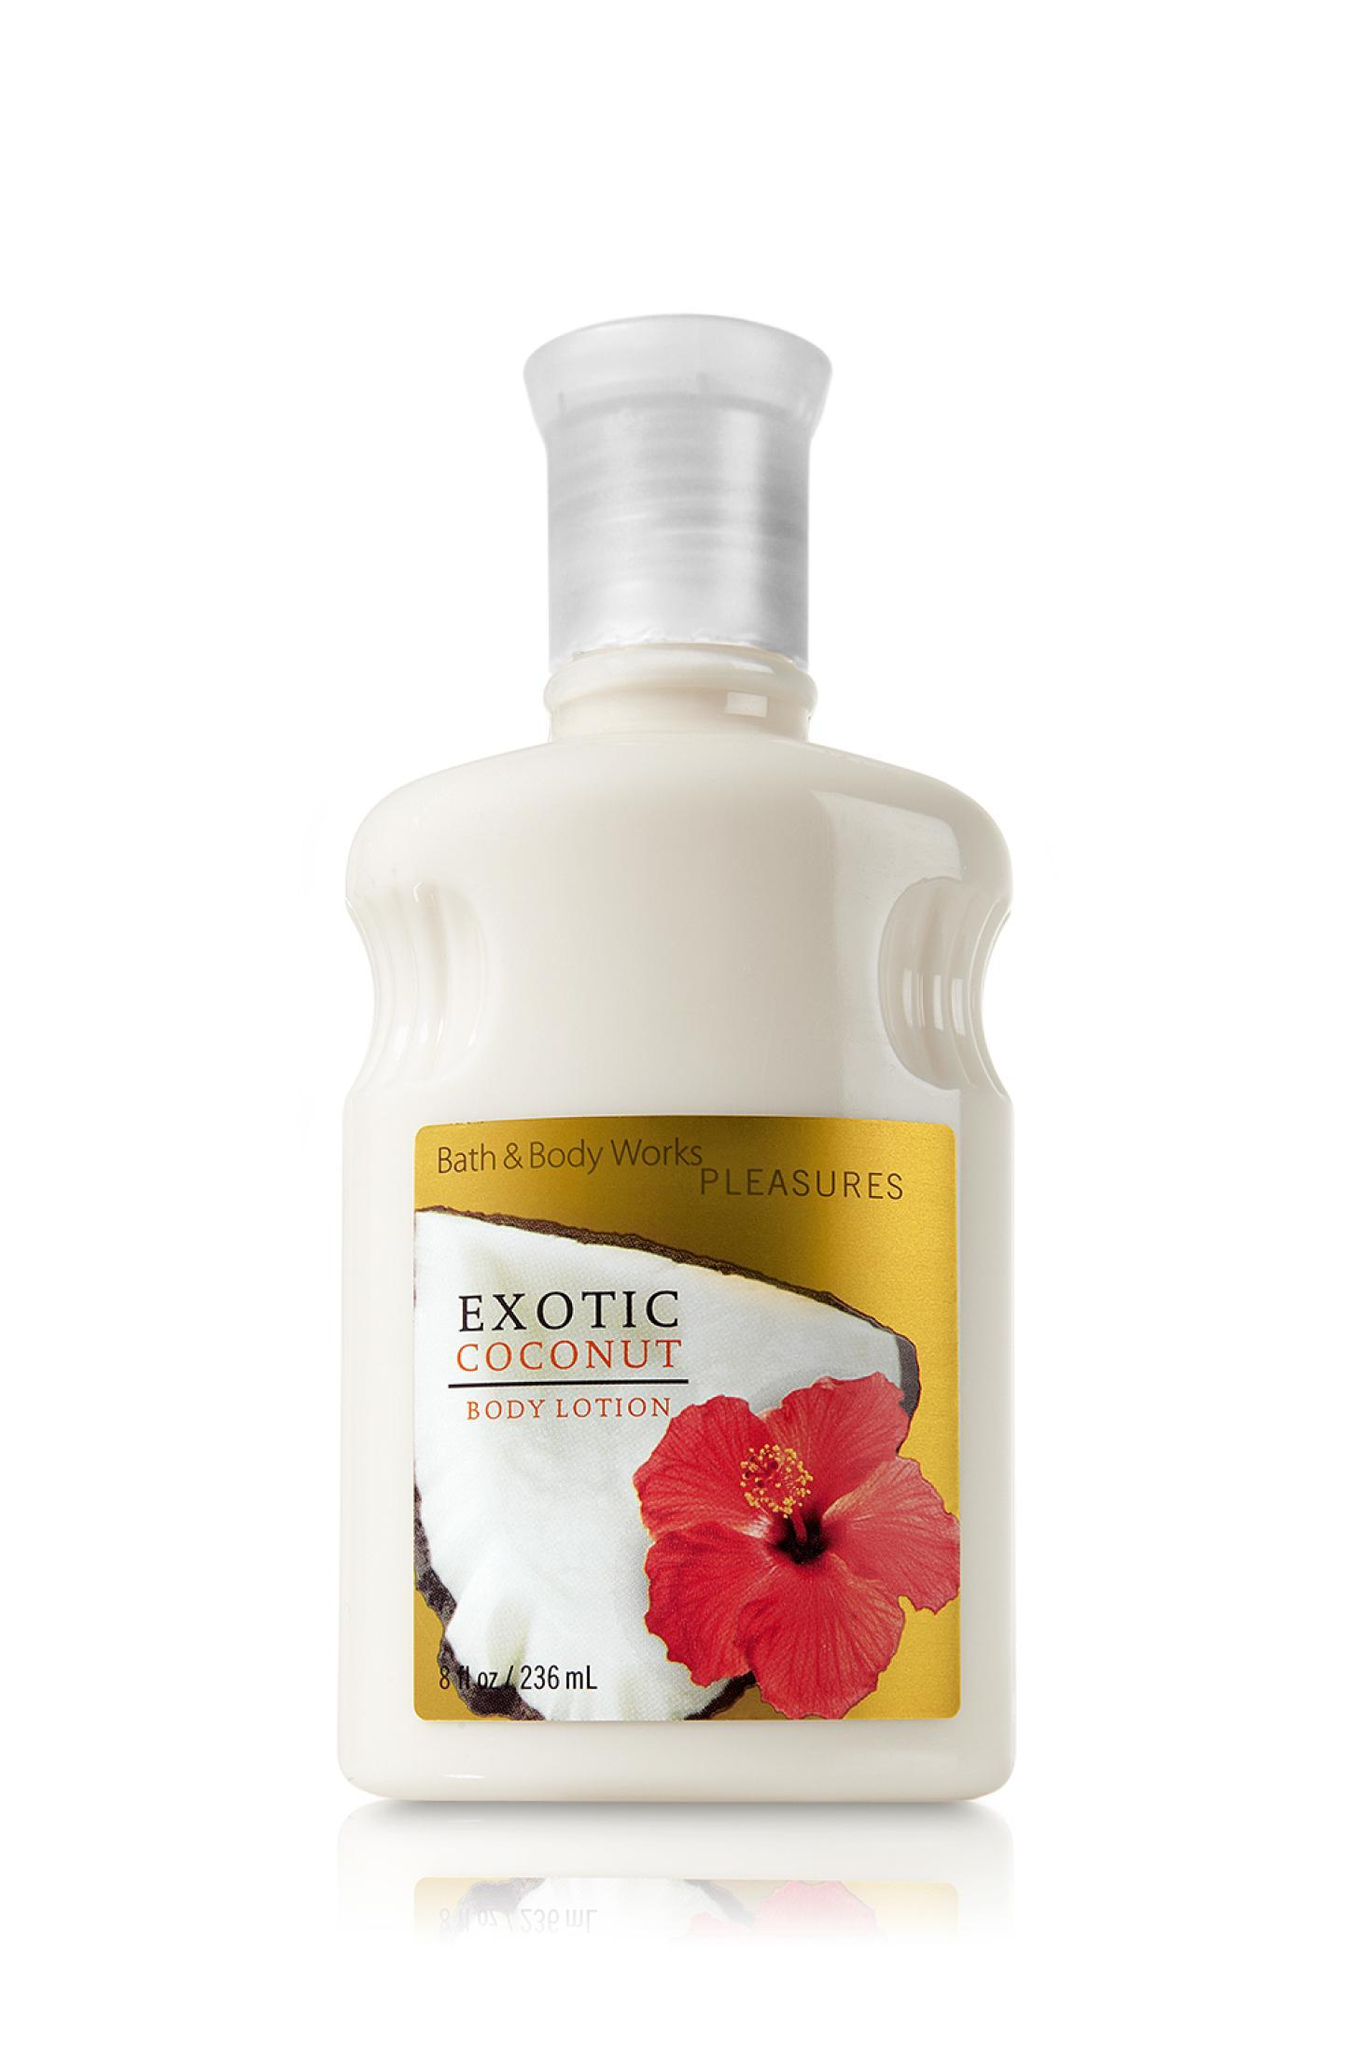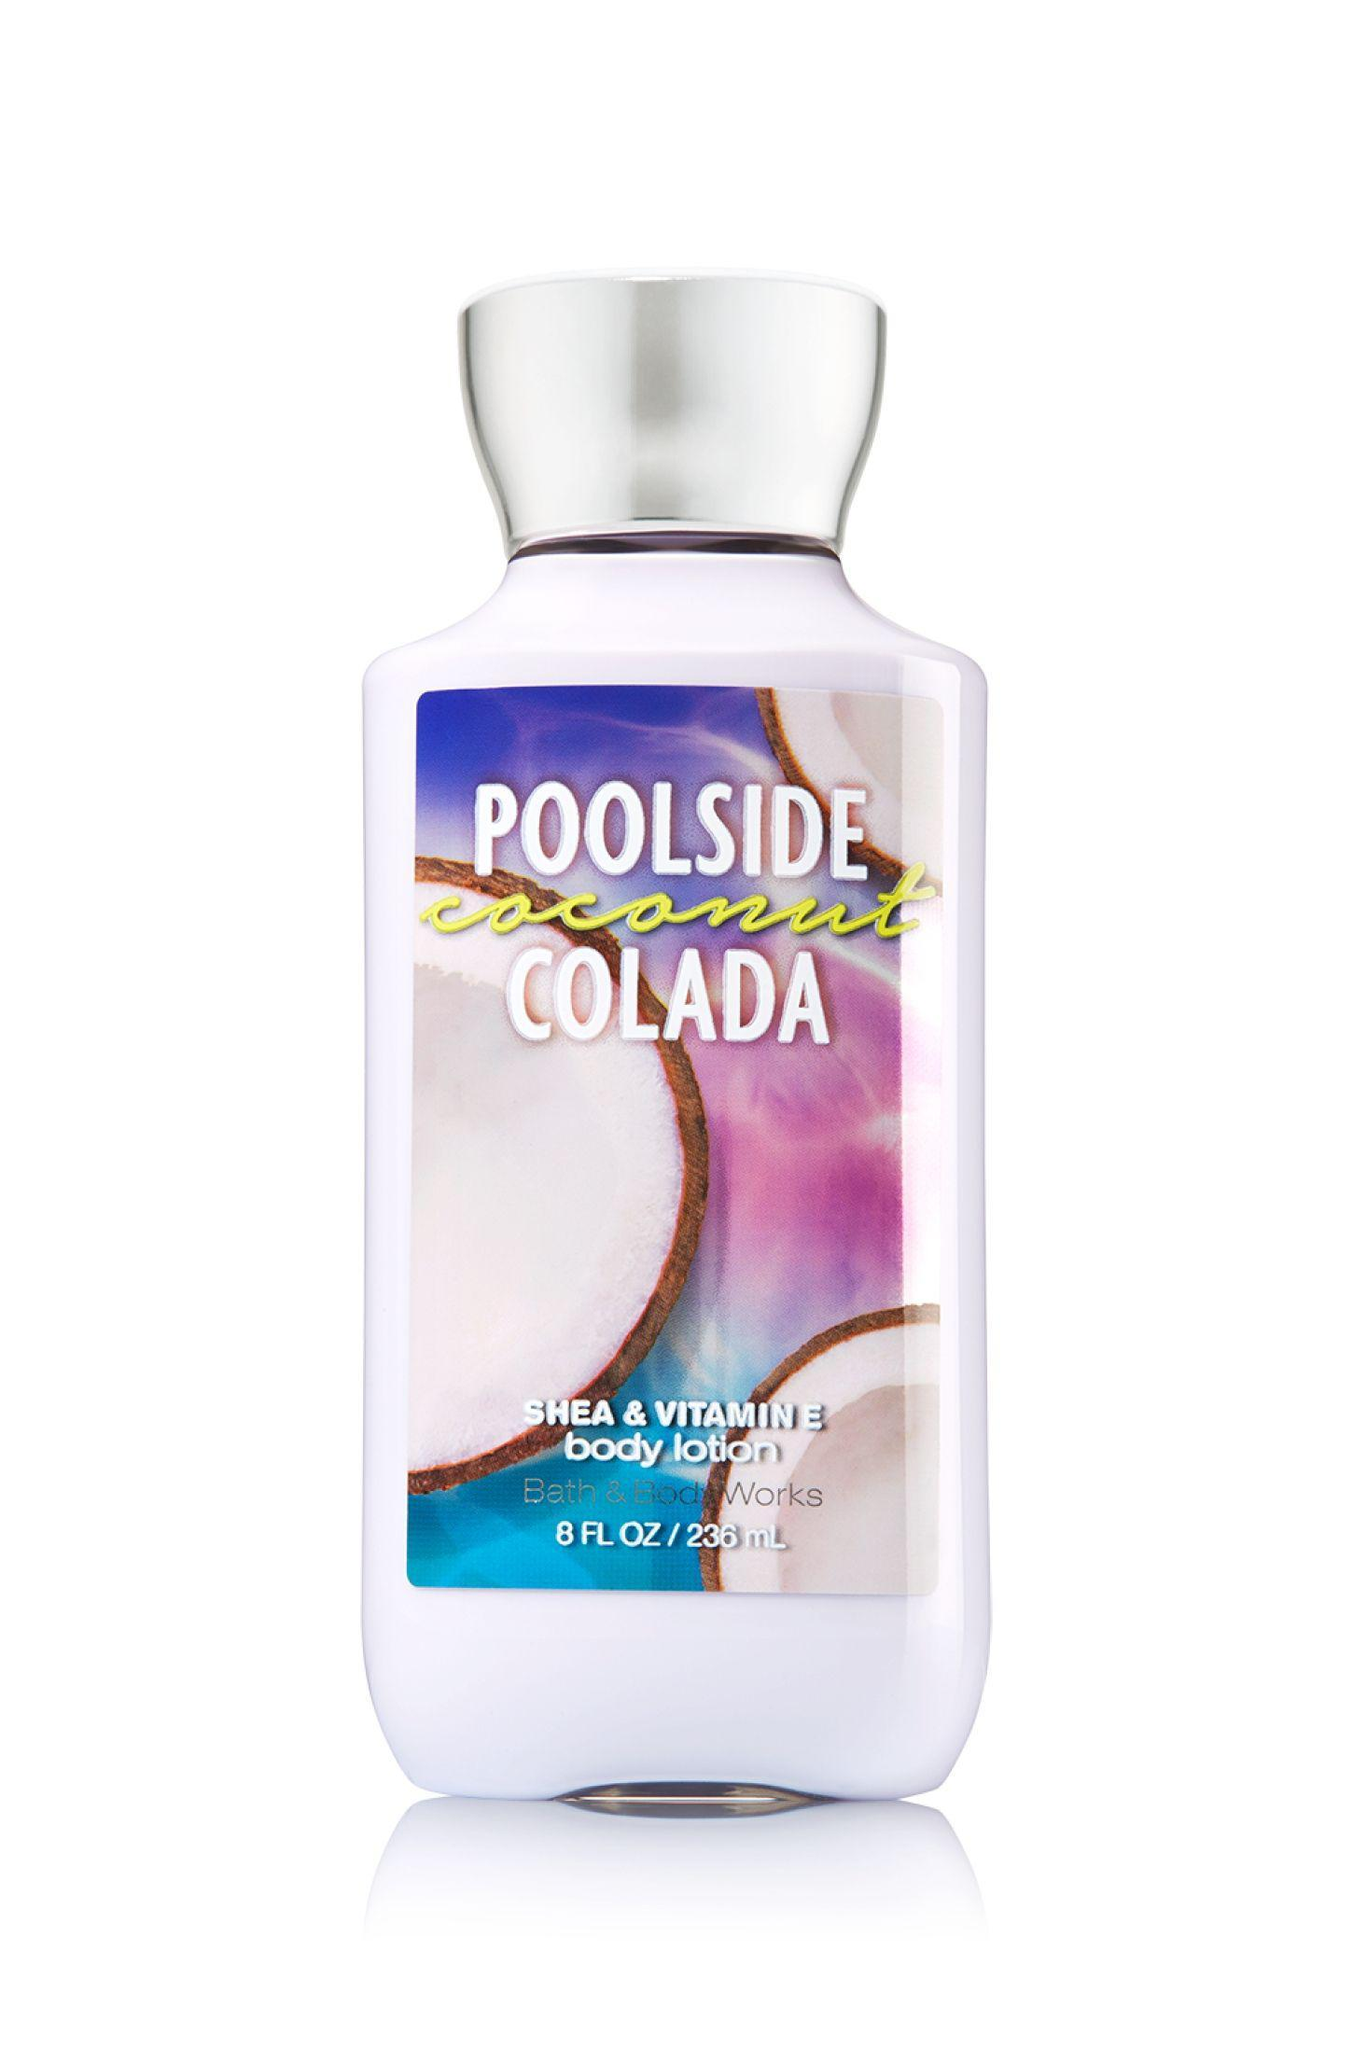The first image is the image on the left, the second image is the image on the right. Examine the images to the left and right. Is the description "There are exactly two objects standing." accurate? Answer yes or no. Yes. The first image is the image on the left, the second image is the image on the right. Evaluate the accuracy of this statement regarding the images: "The left image shows a bottle of white lotion.". Is it true? Answer yes or no. Yes. 